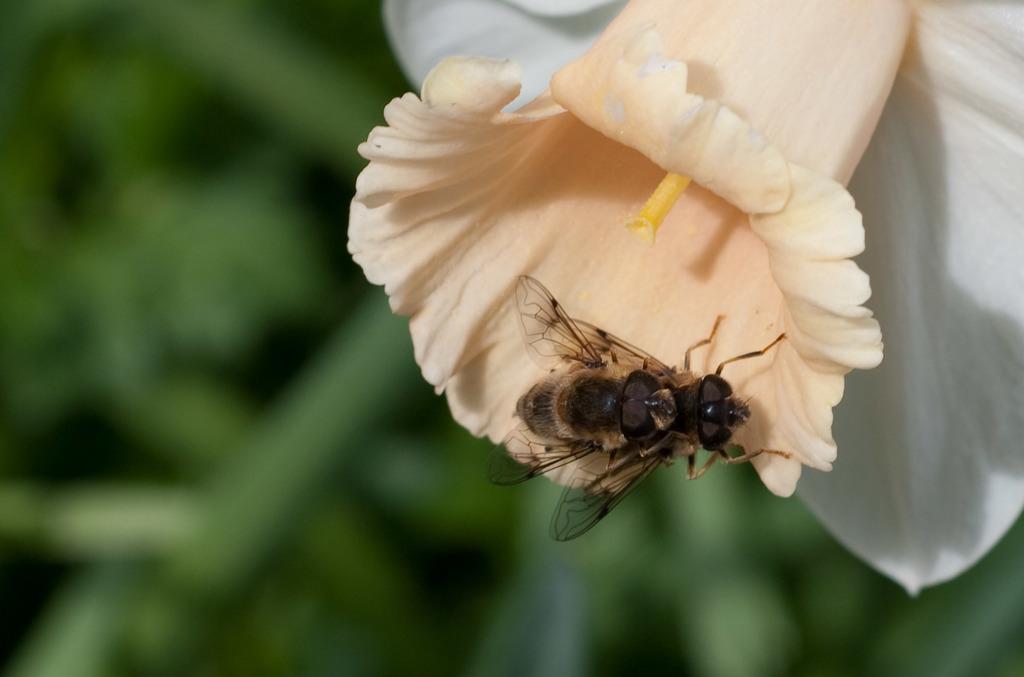Please provide a concise description of this image. In this picture I can observe flower in the middle of the picture. There is an insect on the flower. The background is blurred. 